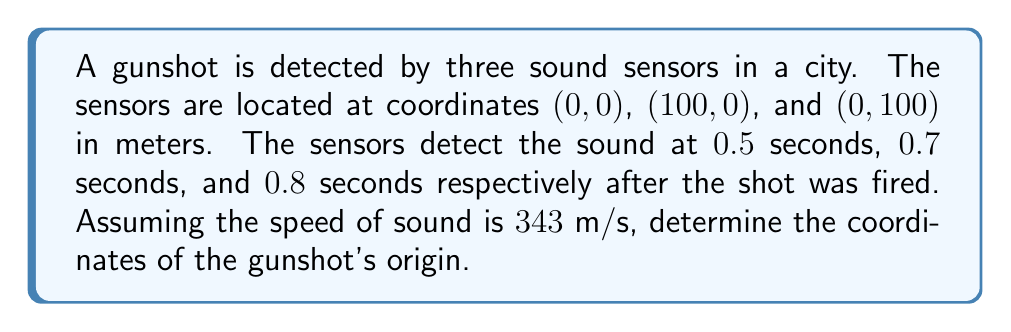Show me your answer to this math problem. To solve this problem, we'll use the concept of triangulation and the time differences between sensor detections.

Step 1: Calculate the distances from the gunshot to each sensor.
Distance = Speed × Time
Sensor 1: $d_1 = 343 \text{ m/s} \times 0.5 \text{ s} = 171.5 \text{ m}$
Sensor 2: $d_2 = 343 \text{ m/s} \times 0.7 \text{ s} = 240.1 \text{ m}$
Sensor 3: $d_3 = 343 \text{ m/s} \times 0.8 \text{ s} = 274.4 \text{ m}$

Step 2: Set up equations based on the distance formula.
Let $(x, y)$ be the coordinates of the gunshot origin.
Sensor 1: $x^2 + y^2 = 171.5^2$
Sensor 2: $(x - 100)^2 + y^2 = 240.1^2$
Sensor 3: $x^2 + (y - 100)^2 = 274.4^2$

Step 3: Solve the system of equations.
Subtracting equation 1 from equation 2:
$x^2 - (x - 100)^2 = 171.5^2 - 240.1^2$
$-200x + 10000 = -29376.36$
$x = 196.88 \text{ m}$

Substituting this x-value into equation 1:
$196.88^2 + y^2 = 171.5^2$
$y^2 = 171.5^2 - 196.88^2 = -11080.87$
$y = 105.27 \text{ m}$

Step 4: Verify the solution using equation 3 (optional).

Therefore, the coordinates of the gunshot origin are approximately (196.88 m, 105.27 m).
Answer: (196.88, 105.27) meters 